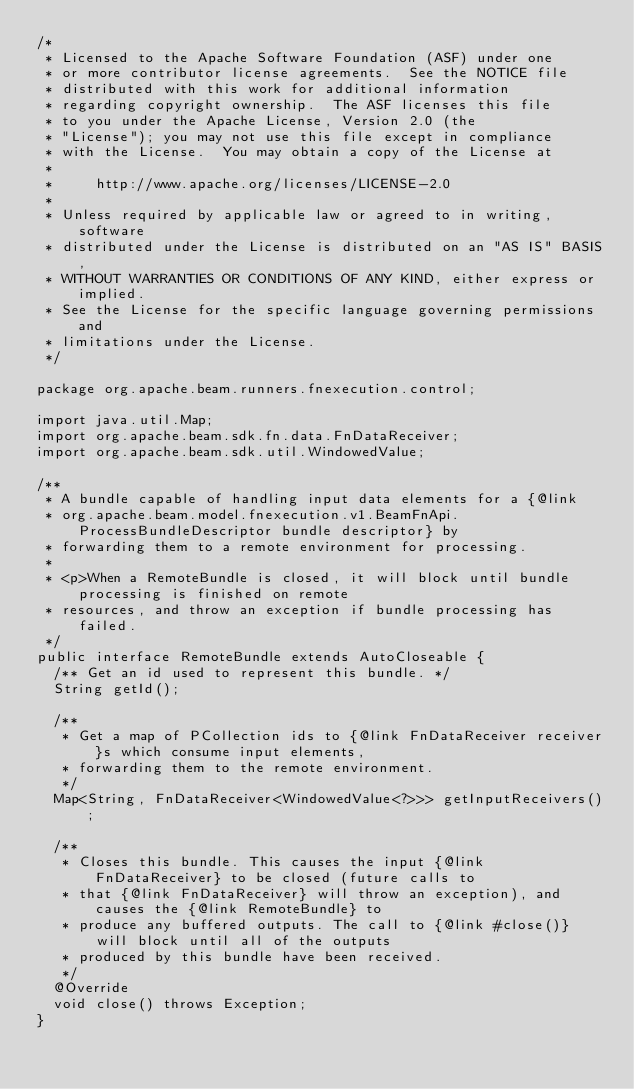<code> <loc_0><loc_0><loc_500><loc_500><_Java_>/*
 * Licensed to the Apache Software Foundation (ASF) under one
 * or more contributor license agreements.  See the NOTICE file
 * distributed with this work for additional information
 * regarding copyright ownership.  The ASF licenses this file
 * to you under the Apache License, Version 2.0 (the
 * "License"); you may not use this file except in compliance
 * with the License.  You may obtain a copy of the License at
 *
 *     http://www.apache.org/licenses/LICENSE-2.0
 *
 * Unless required by applicable law or agreed to in writing, software
 * distributed under the License is distributed on an "AS IS" BASIS,
 * WITHOUT WARRANTIES OR CONDITIONS OF ANY KIND, either express or implied.
 * See the License for the specific language governing permissions and
 * limitations under the License.
 */

package org.apache.beam.runners.fnexecution.control;

import java.util.Map;
import org.apache.beam.sdk.fn.data.FnDataReceiver;
import org.apache.beam.sdk.util.WindowedValue;

/**
 * A bundle capable of handling input data elements for a {@link
 * org.apache.beam.model.fnexecution.v1.BeamFnApi.ProcessBundleDescriptor bundle descriptor} by
 * forwarding them to a remote environment for processing.
 *
 * <p>When a RemoteBundle is closed, it will block until bundle processing is finished on remote
 * resources, and throw an exception if bundle processing has failed.
 */
public interface RemoteBundle extends AutoCloseable {
  /** Get an id used to represent this bundle. */
  String getId();

  /**
   * Get a map of PCollection ids to {@link FnDataReceiver receiver}s which consume input elements,
   * forwarding them to the remote environment.
   */
  Map<String, FnDataReceiver<WindowedValue<?>>> getInputReceivers();

  /**
   * Closes this bundle. This causes the input {@link FnDataReceiver} to be closed (future calls to
   * that {@link FnDataReceiver} will throw an exception), and causes the {@link RemoteBundle} to
   * produce any buffered outputs. The call to {@link #close()} will block until all of the outputs
   * produced by this bundle have been received.
   */
  @Override
  void close() throws Exception;
}
</code> 